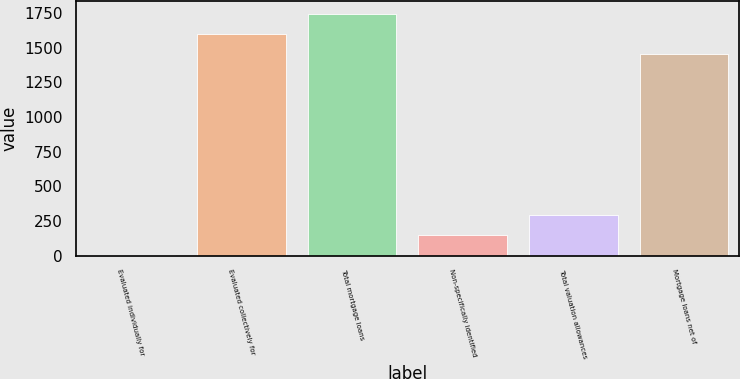<chart> <loc_0><loc_0><loc_500><loc_500><bar_chart><fcel>Evaluated individually for<fcel>Evaluated collectively for<fcel>Total mortgage loans<fcel>Non-specifically identified<fcel>Total valuation allowances<fcel>Mortgage loans net of<nl><fcel>3<fcel>1600.8<fcel>1747.6<fcel>149.8<fcel>296.6<fcel>1454<nl></chart> 